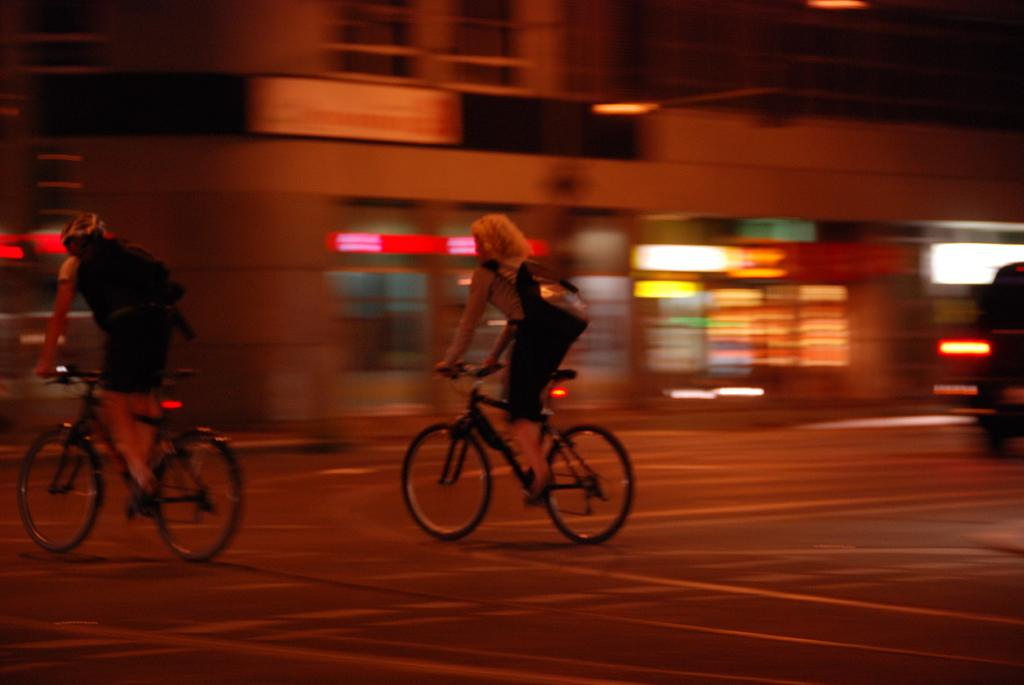What are the people in the image doing? The people in the image are riding bicycles. What can be seen in the background of the image? There is a building visible in the image. What else is present in the image besides the people on bicycles and the building? There is a moving vehicle in the image. What type of pollution can be seen coming from the bicycles in the image? There is no pollution visible coming from the bicycles in the image, as bicycles do not emit pollutants. 